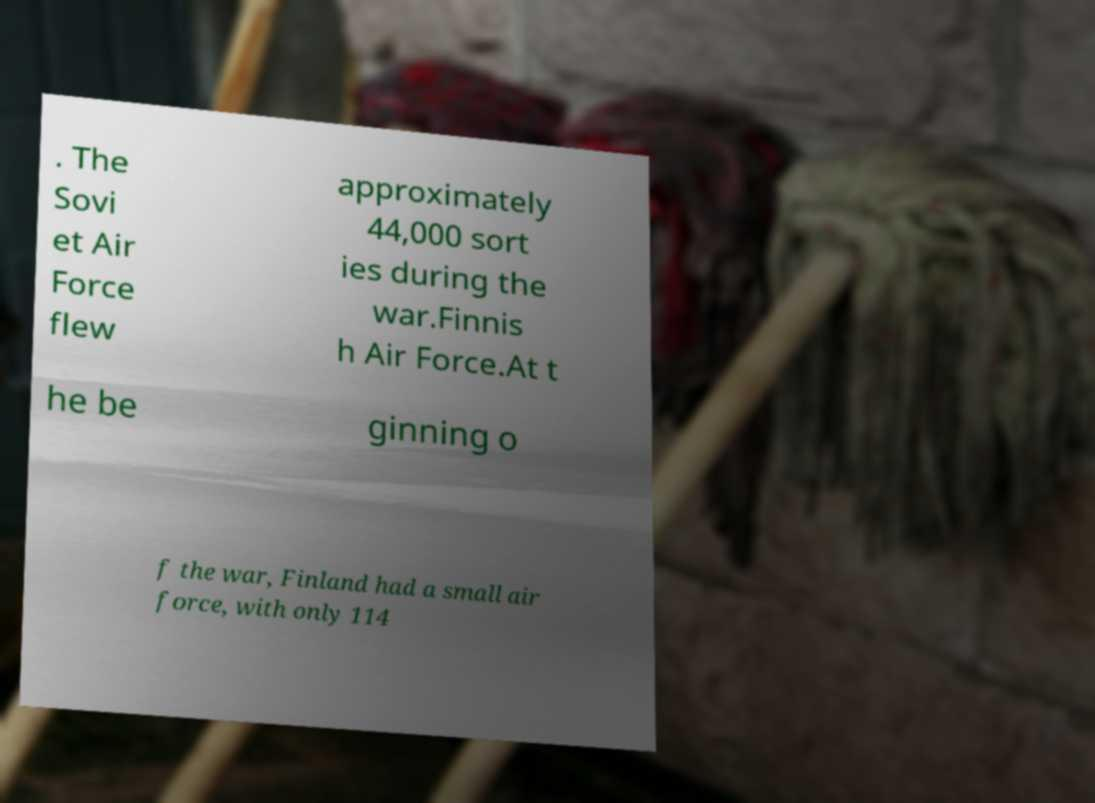Please identify and transcribe the text found in this image. . The Sovi et Air Force flew approximately 44,000 sort ies during the war.Finnis h Air Force.At t he be ginning o f the war, Finland had a small air force, with only 114 